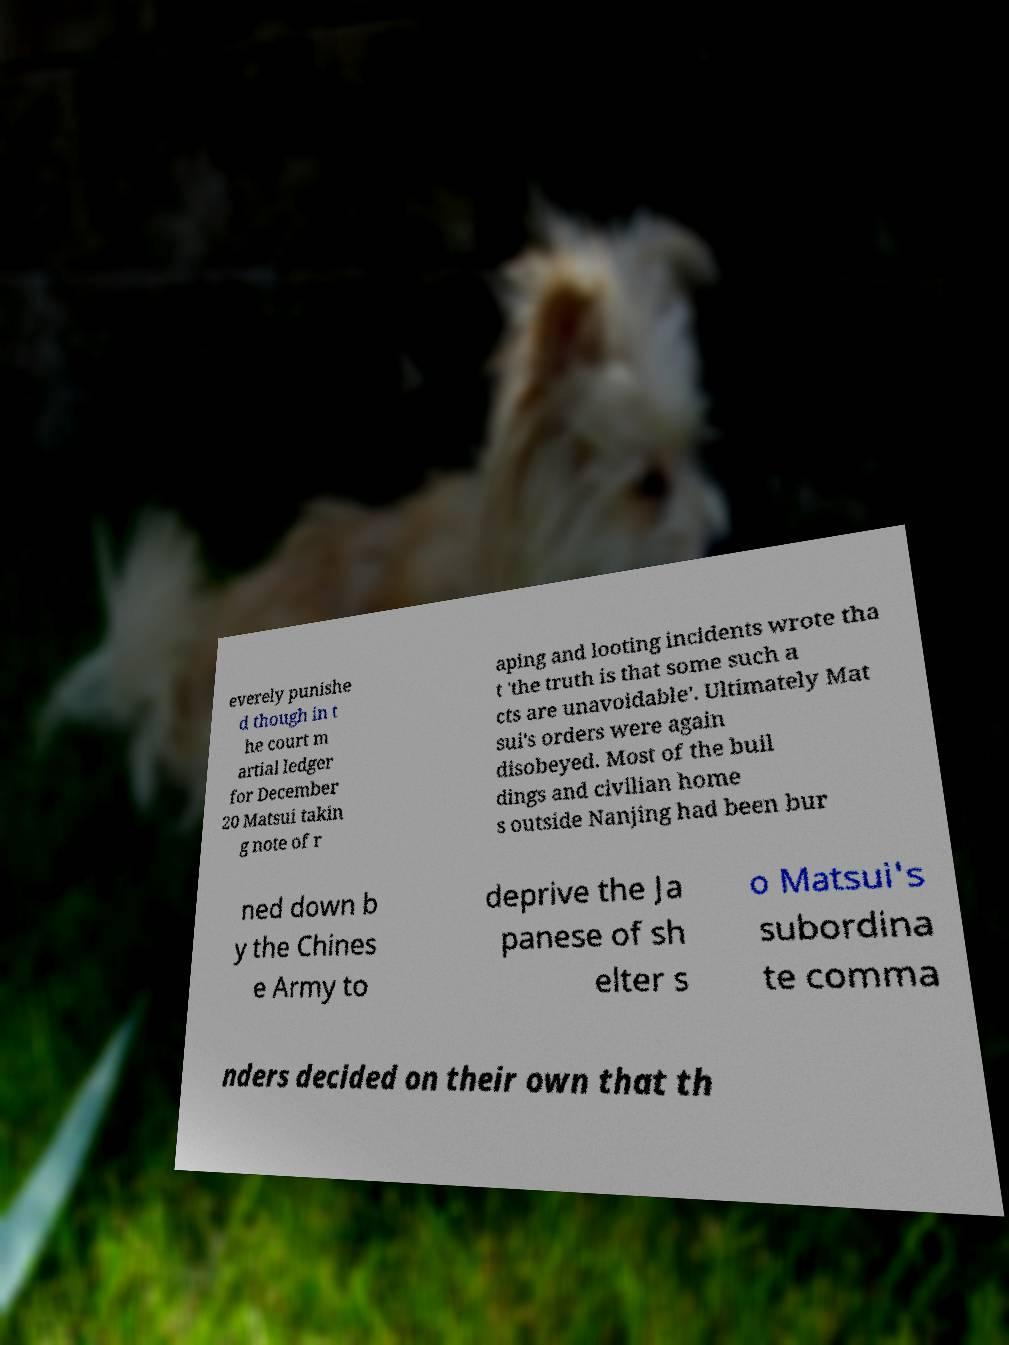Can you accurately transcribe the text from the provided image for me? everely punishe d though in t he court m artial ledger for December 20 Matsui takin g note of r aping and looting incidents wrote tha t 'the truth is that some such a cts are unavoidable'. Ultimately Mat sui's orders were again disobeyed. Most of the buil dings and civilian home s outside Nanjing had been bur ned down b y the Chines e Army to deprive the Ja panese of sh elter s o Matsui's subordina te comma nders decided on their own that th 